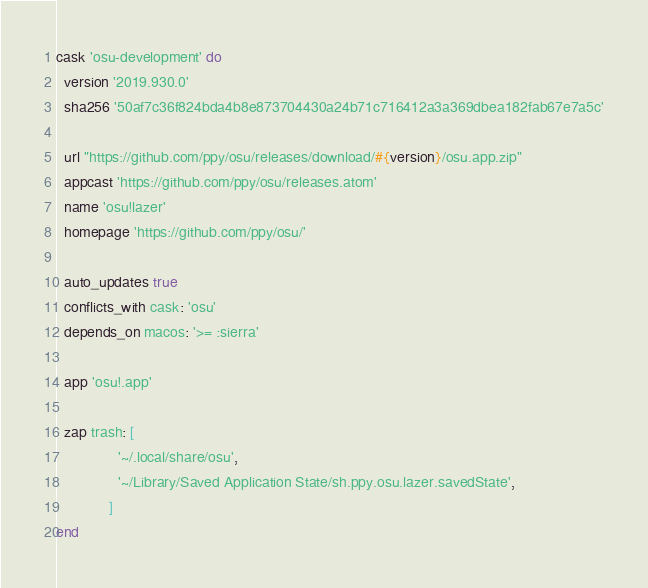<code> <loc_0><loc_0><loc_500><loc_500><_Ruby_>cask 'osu-development' do
  version '2019.930.0'
  sha256 '50af7c36f824bda4b8e873704430a24b71c716412a3a369dbea182fab67e7a5c'

  url "https://github.com/ppy/osu/releases/download/#{version}/osu.app.zip"
  appcast 'https://github.com/ppy/osu/releases.atom'
  name 'osu!lazer'
  homepage 'https://github.com/ppy/osu/'

  auto_updates true
  conflicts_with cask: 'osu'
  depends_on macos: '>= :sierra'

  app 'osu!.app'

  zap trash: [
               '~/.local/share/osu',
               '~/Library/Saved Application State/sh.ppy.osu.lazer.savedState',
             ]
end
</code> 